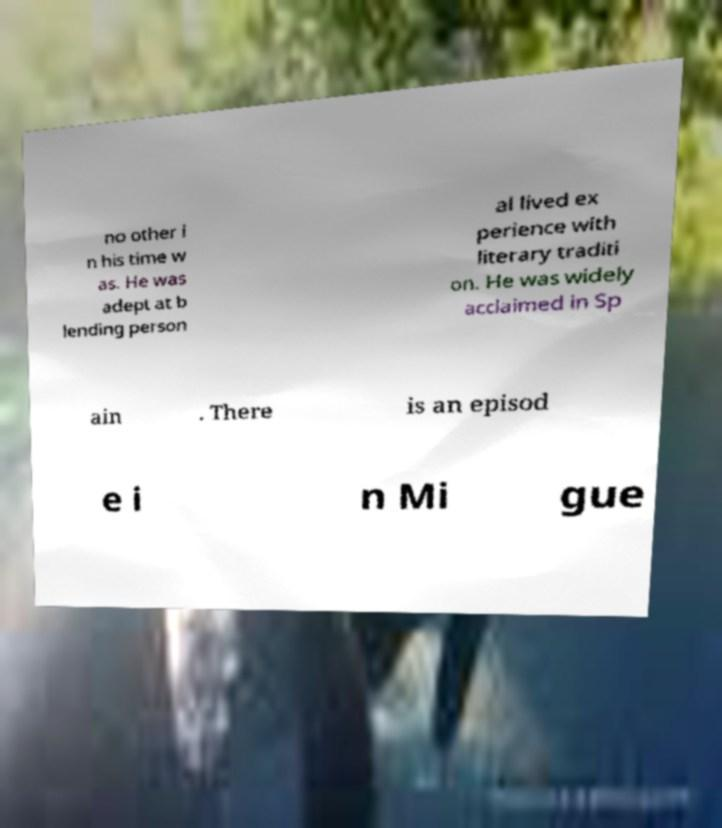Please read and relay the text visible in this image. What does it say? no other i n his time w as. He was adept at b lending person al lived ex perience with literary traditi on. He was widely acclaimed in Sp ain . There is an episod e i n Mi gue 